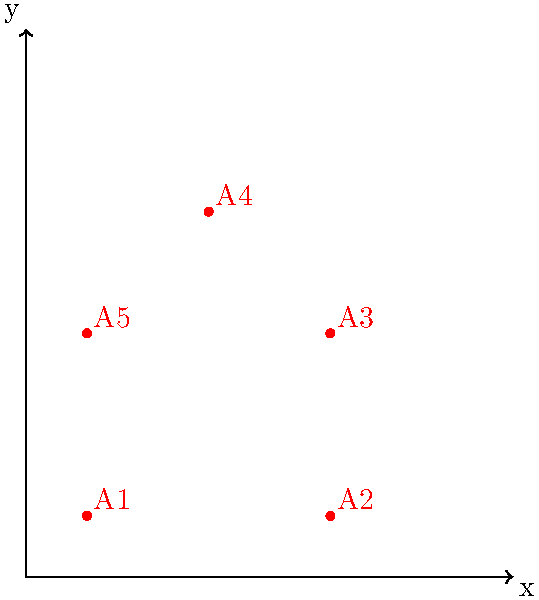As part of an initiative to create more inclusive playgrounds, you are tasked with transforming an existing playground design. The original design is represented by the red shape ABCDE, and the transformed design is represented by the blue shape A'B'C'D'E'. If the transformation involves a dilation with scale factor k and a vertical stretch by a factor of 1.5, what is the value of k? To find the scale factor k, we need to compare the horizontal dimensions of the original and transformed shapes, as the vertical stretch doesn't affect these dimensions.

Step 1: Identify corresponding horizontal distances.
- Original width: x-coordinate of B - x-coordinate of A = 4 - 0 = 4
- Transformed width: x-coordinate of B' - x-coordinate of A' = 6 - 0 = 6

Step 2: Calculate the scale factor k.
The scale factor k is the ratio of the transformed width to the original width.

$$k = \frac{\text{Transformed width}}{\text{Original width}} = \frac{6}{4} = 1.5$$

Step 3: Verify the vertical stretch.
To confirm our answer, we can check if the vertical dimensions have been stretched by a factor of 1.5 in addition to the dilation:

Original height: 5 units
Expected transformed height: $5 \times 1.5 \times 1.5 = 11.25$ units

Actual transformed height: 7.5 units

Indeed, $7.5 = 5 \times 1.5$ (dilation) $\times 1.5$ (vertical stretch)

Therefore, the scale factor k for the dilation is 1.5.
Answer: 1.5 